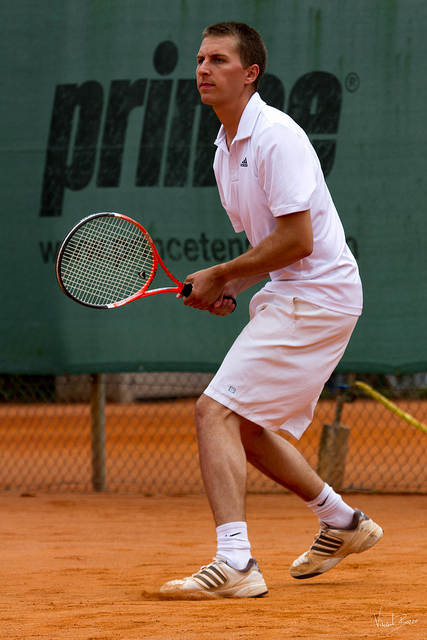<image>What lime green letter is on the right of the banner? I am not sure what the lime green letter on the right of the banner is. It might be 'e' or 'p'. What lime green letter is on the right of the banner? I am not sure which lime green letter is on the right of the banner. It can be seen 'e', 'prime' or 'p'. 